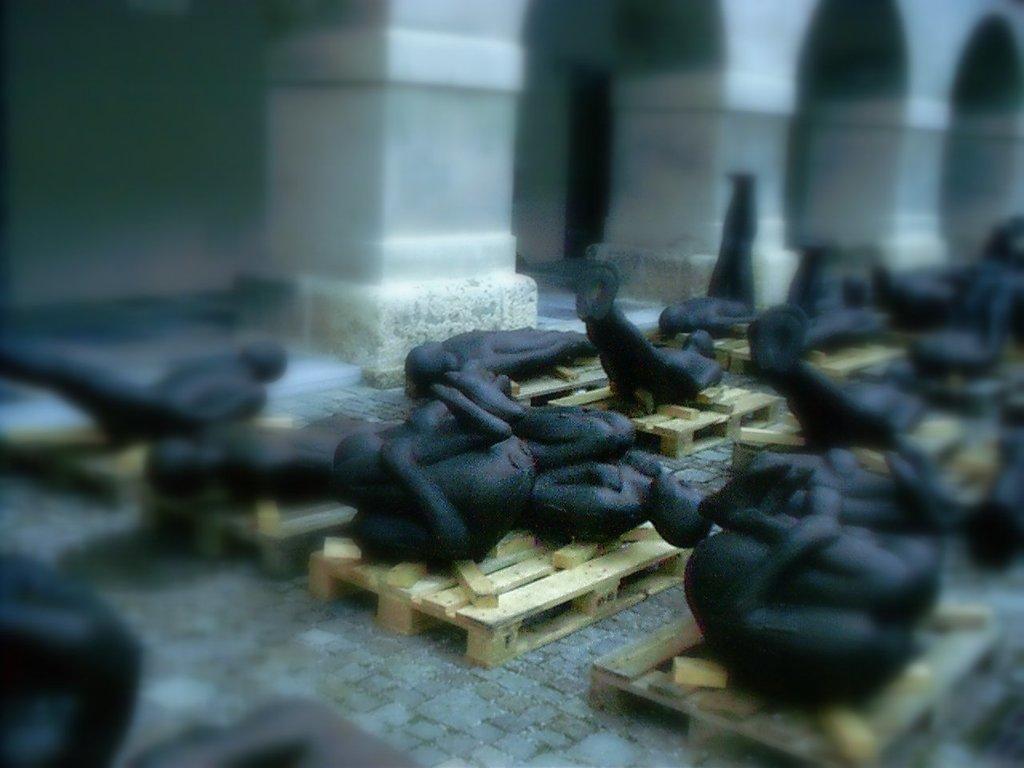Could you give a brief overview of what you see in this image? These are the statues of a human beings on the wooden things. 